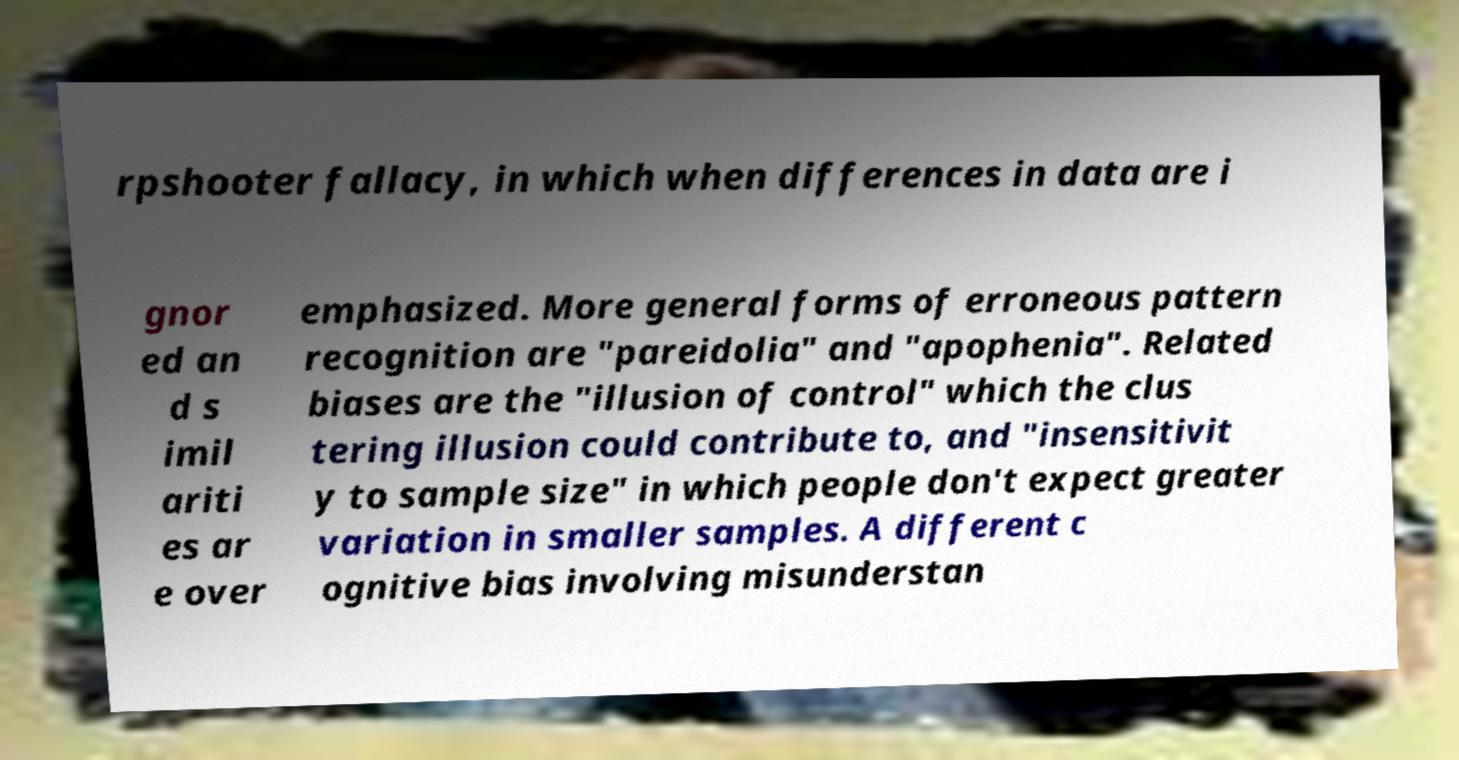Can you read and provide the text displayed in the image?This photo seems to have some interesting text. Can you extract and type it out for me? rpshooter fallacy, in which when differences in data are i gnor ed an d s imil ariti es ar e over emphasized. More general forms of erroneous pattern recognition are "pareidolia" and "apophenia". Related biases are the "illusion of control" which the clus tering illusion could contribute to, and "insensitivit y to sample size" in which people don't expect greater variation in smaller samples. A different c ognitive bias involving misunderstan 